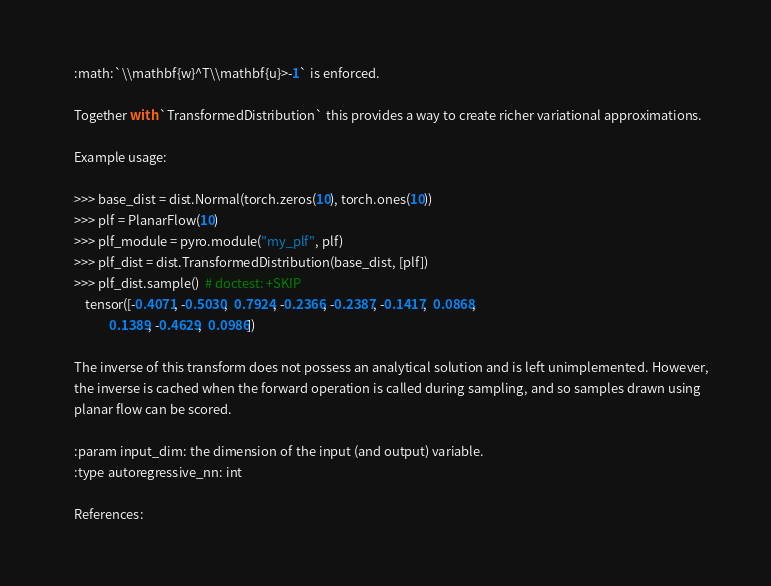Convert code to text. <code><loc_0><loc_0><loc_500><loc_500><_Python_>    :math:`\\mathbf{w}^T\\mathbf{u}>-1` is enforced.

    Together with `TransformedDistribution` this provides a way to create richer variational approximations.

    Example usage:

    >>> base_dist = dist.Normal(torch.zeros(10), torch.ones(10))
    >>> plf = PlanarFlow(10)
    >>> plf_module = pyro.module("my_plf", plf)
    >>> plf_dist = dist.TransformedDistribution(base_dist, [plf])
    >>> plf_dist.sample()  # doctest: +SKIP
        tensor([-0.4071, -0.5030,  0.7924, -0.2366, -0.2387, -0.1417,  0.0868,
                0.1389, -0.4629,  0.0986])

    The inverse of this transform does not possess an analytical solution and is left unimplemented. However,
    the inverse is cached when the forward operation is called during sampling, and so samples drawn using
    planar flow can be scored.

    :param input_dim: the dimension of the input (and output) variable.
    :type autoregressive_nn: int

    References:
</code> 